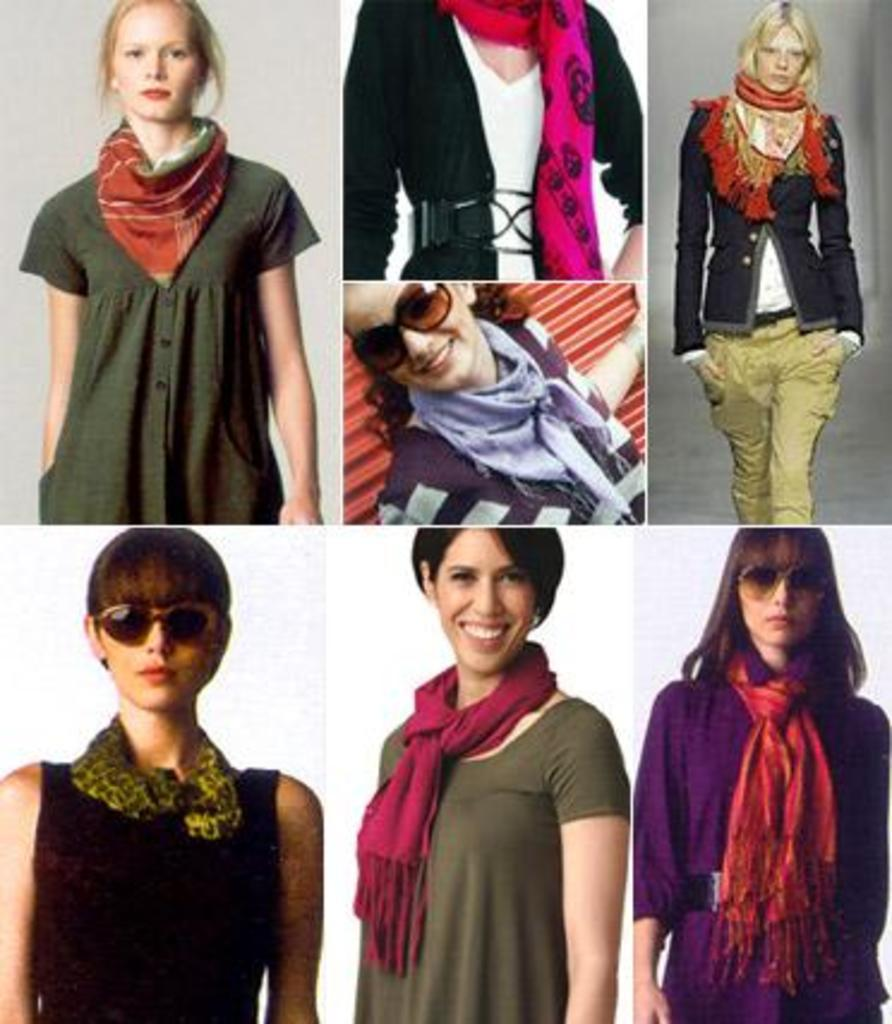What type of photos are present in the image? The image contains collage photos of women. What is a common accessory worn by the women in the photos? Most of the women in the photos are wearing scarves. What type of eyewear can be seen on some of the women in the photos? Some of the women in the photos are wearing shades. What emotion can be observed on some of the faces in the photos? There are smiles visible on some of the faces in the photos. What type of chalk is being used to draw on the home in the image? There is no chalk or home present in the image; it features a collage of photos of women. What type of produce can be seen in the image? There is no produce visible in the image; it features a collage of photos of women. 